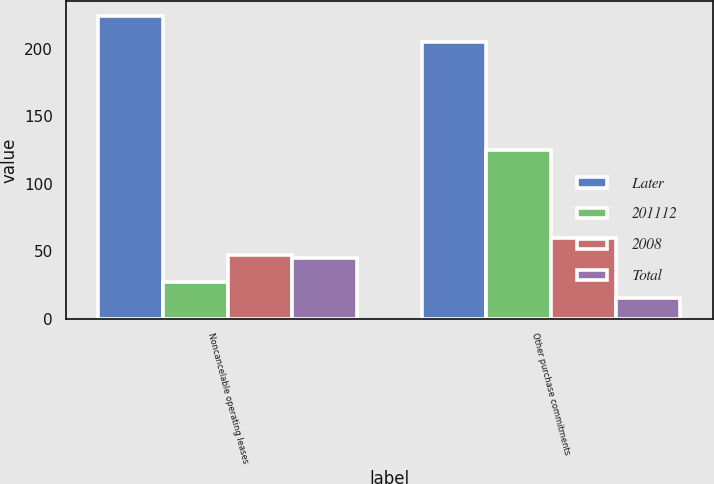<chart> <loc_0><loc_0><loc_500><loc_500><stacked_bar_chart><ecel><fcel>Noncancelable operating leases<fcel>Other purchase commitments<nl><fcel>Later<fcel>224<fcel>205<nl><fcel>201112<fcel>27<fcel>125<nl><fcel>2008<fcel>47<fcel>60<nl><fcel>Total<fcel>45<fcel>15<nl></chart> 